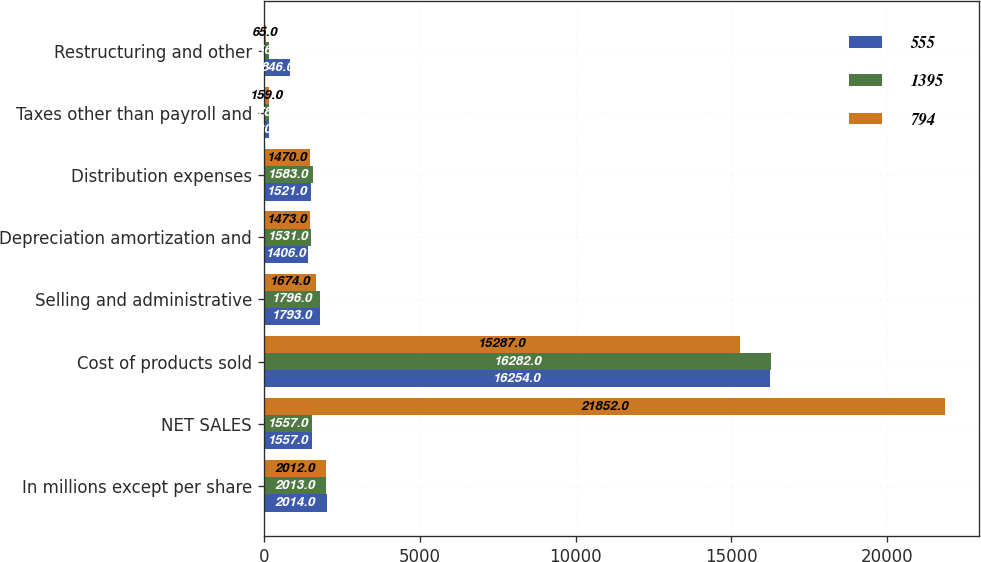Convert chart to OTSL. <chart><loc_0><loc_0><loc_500><loc_500><stacked_bar_chart><ecel><fcel>In millions except per share<fcel>NET SALES<fcel>Cost of products sold<fcel>Selling and administrative<fcel>Depreciation amortization and<fcel>Distribution expenses<fcel>Taxes other than payroll and<fcel>Restructuring and other<nl><fcel>555<fcel>2014<fcel>1557<fcel>16254<fcel>1793<fcel>1406<fcel>1521<fcel>180<fcel>846<nl><fcel>1395<fcel>2013<fcel>1557<fcel>16282<fcel>1796<fcel>1531<fcel>1583<fcel>178<fcel>156<nl><fcel>794<fcel>2012<fcel>21852<fcel>15287<fcel>1674<fcel>1473<fcel>1470<fcel>159<fcel>65<nl></chart> 